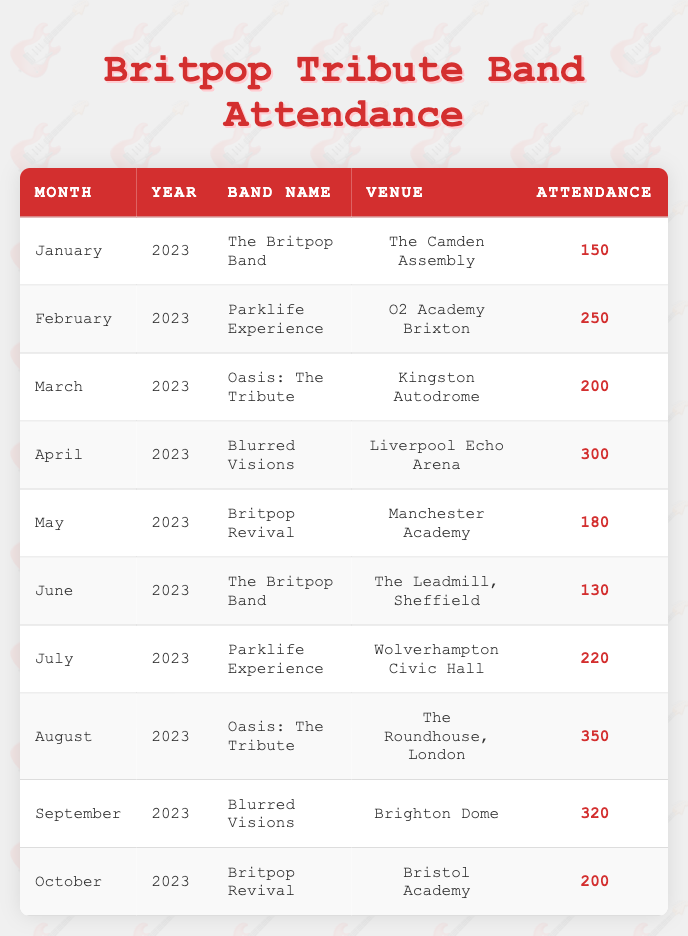What was the attendance for "Blurred Visions" in September 2023? The table indicates that "Blurred Visions" performed in September 2023 with an attendance of 320.
Answer: 320 Which band had the highest attendance and what was the attendance figure? By reviewing the attendance figures in the table, "Oasis: The Tribute" had the highest attendance with 350 in August 2023.
Answer: Oasis: The Tribute, 350 What was the total attendance across all performances in July and August 2023? In July, the attendance was 220 for "Parklife Experience," and in August, it was 350 for "Oasis: The Tribute." Adding these figures gives 220 + 350 = 570.
Answer: 570 Did "Britpop Revival" perform more than once in 2023? The table shows performances for "Britpop Revival" in May and October. This indicates that they did perform more than once in 2023.
Answer: Yes What was the average attendance for "The Britpop Band" in 2023? "The Britpop Band" performed in January (150) and June (130). The average attendance is calculated by taking the sum (150 + 130 = 280) and dividing by the number of performances (2), resulting in 280/2 = 140.
Answer: 140 How many venues had an attendance of over 300 people? The table lists two performances with attendance over 300: "Blurred Visions" in April (300) and "Oasis: The Tribute" in August (350). This means there were 2 venues with over 300 attendees.
Answer: 2 What was the difference in attendance between "Britpop Revival" in May and "Parklife Experience" in July? Attendance for "Britpop Revival" in May was 180, while "Parklife Experience" in July had 220. The difference is calculated as 220 - 180 = 40.
Answer: 40 Which venue had the lowest attendance in January 2023? The attendance at "The Camden Assembly" for "The Britpop Band" in January 2023 was 150, which is the lowest figure in that month.
Answer: The Camden Assembly, 150 What percentage of attendance was achieved by "Oasis: The Tribute" in August compared to the total attendance for all bands in that month? In August, "Oasis: The Tribute" had 350 attendees. The total attendance for that month (which is only 350 since it's the sole performance) means the percentage is (350/350) * 100 = 100%.
Answer: 100% 